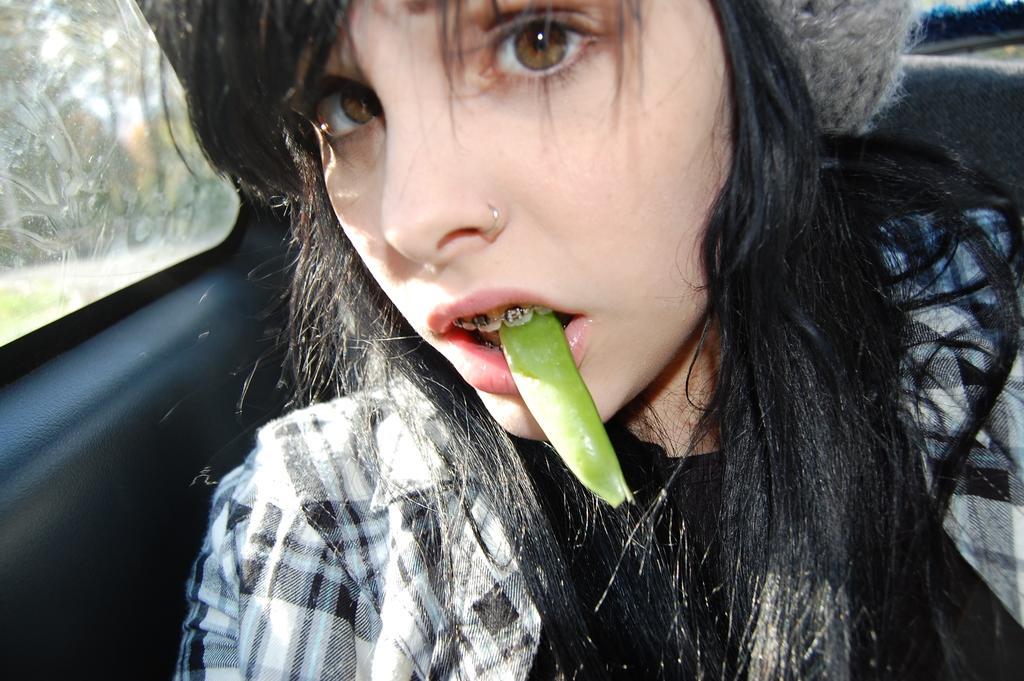Could you give a brief overview of what you see in this image? In this picture we can see a girl in a vehicle with a green color object in her mouth and in the background we can see trees. 